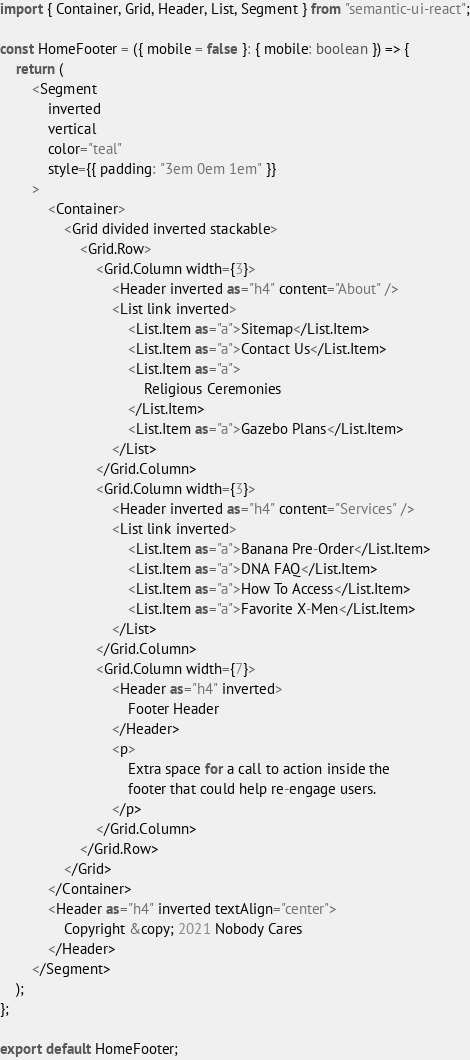<code> <loc_0><loc_0><loc_500><loc_500><_TypeScript_>import { Container, Grid, Header, List, Segment } from "semantic-ui-react";

const HomeFooter = ({ mobile = false }: { mobile: boolean }) => {
    return (
        <Segment
            inverted
            vertical
            color="teal"
            style={{ padding: "3em 0em 1em" }}
        >
            <Container>
                <Grid divided inverted stackable>
                    <Grid.Row>
                        <Grid.Column width={3}>
                            <Header inverted as="h4" content="About" />
                            <List link inverted>
                                <List.Item as="a">Sitemap</List.Item>
                                <List.Item as="a">Contact Us</List.Item>
                                <List.Item as="a">
                                    Religious Ceremonies
                                </List.Item>
                                <List.Item as="a">Gazebo Plans</List.Item>
                            </List>
                        </Grid.Column>
                        <Grid.Column width={3}>
                            <Header inverted as="h4" content="Services" />
                            <List link inverted>
                                <List.Item as="a">Banana Pre-Order</List.Item>
                                <List.Item as="a">DNA FAQ</List.Item>
                                <List.Item as="a">How To Access</List.Item>
                                <List.Item as="a">Favorite X-Men</List.Item>
                            </List>
                        </Grid.Column>
                        <Grid.Column width={7}>
                            <Header as="h4" inverted>
                                Footer Header
                            </Header>
                            <p>
                                Extra space for a call to action inside the
                                footer that could help re-engage users.
                            </p>
                        </Grid.Column>
                    </Grid.Row>
                </Grid>
            </Container>
            <Header as="h4" inverted textAlign="center">
                Copyright &copy; 2021 Nobody Cares
            </Header>
        </Segment>
    );
};

export default HomeFooter;
</code> 